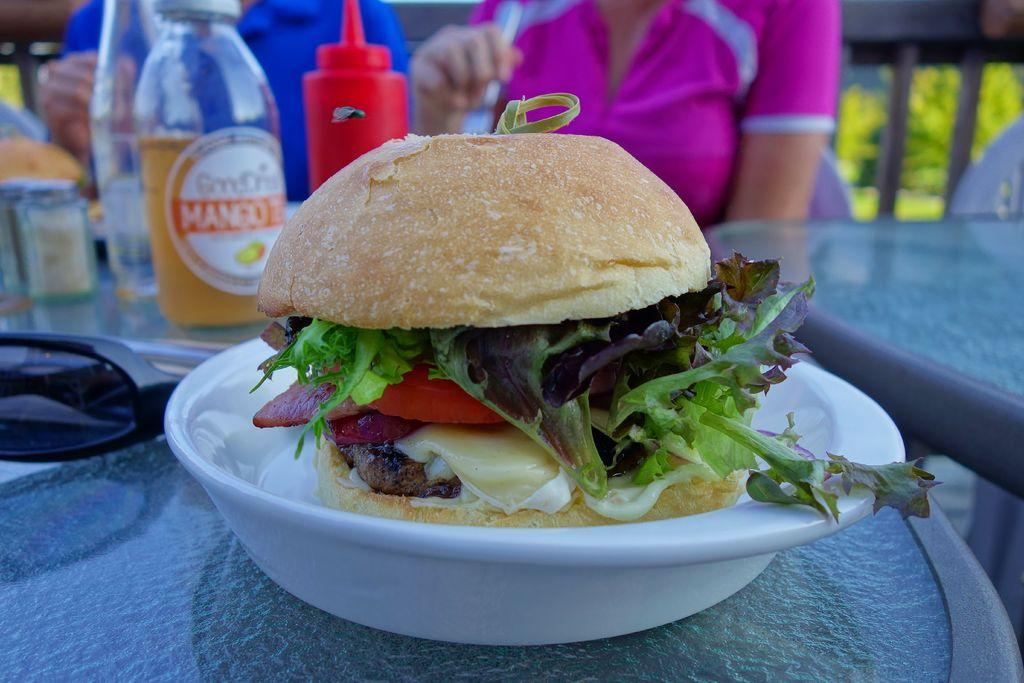What is on the plate in the image? There is food on the plate in the image. What can be seen in the background of the image? There are people visible in the background of the image. What else is on the table in the background of the image? There are items on the table in the background of the image. What type of rose is being held by the person in the image? There is no rose present in the image. How does the office setting contribute to the atmosphere of the image? There is no mention of an office setting in the image, so it cannot contribute to the atmosphere. 